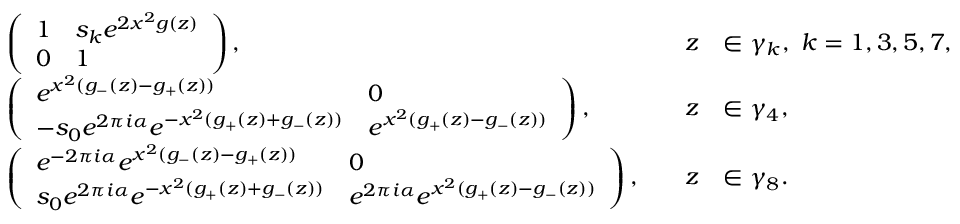<formula> <loc_0><loc_0><loc_500><loc_500>\begin{array} { r l r l } & { \left ( \begin{array} { l l } { 1 } & { s _ { k } e ^ { 2 x ^ { 2 } g ( z ) } } \\ { 0 } & { 1 } \end{array} \right ) , \quad } & { z } & { \in \gamma _ { k } , \ k = 1 , 3 , 5 , 7 , } \\ & { \left ( \begin{array} { l l } { e ^ { x ^ { 2 } ( g _ { - } ( z ) - g _ { + } ( z ) ) } } & { 0 } \\ { - s _ { 0 } e ^ { 2 \pi i \alpha } e ^ { - x ^ { 2 } ( g _ { + } ( z ) + g _ { - } ( z ) ) } } & { e ^ { x ^ { 2 } ( g _ { + } ( z ) - g _ { - } ( z ) ) } } \end{array} \right ) , \quad } & { z } & { \in \gamma _ { 4 } , } \\ & { \left ( \begin{array} { l l } { e ^ { - 2 \pi i \alpha } e ^ { x ^ { 2 } ( g _ { - } ( z ) - g _ { + } ( z ) ) } } & { 0 } \\ { s _ { 0 } e ^ { 2 \pi i \alpha } e ^ { - x ^ { 2 } ( g _ { + } ( z ) + g _ { - } ( z ) ) } } & { e ^ { 2 \pi i \alpha } e ^ { x ^ { 2 } ( g _ { + } ( z ) - g _ { - } ( z ) ) } } \end{array} \right ) , \quad } & { z } & { \in \gamma _ { 8 } . } \end{array}</formula> 